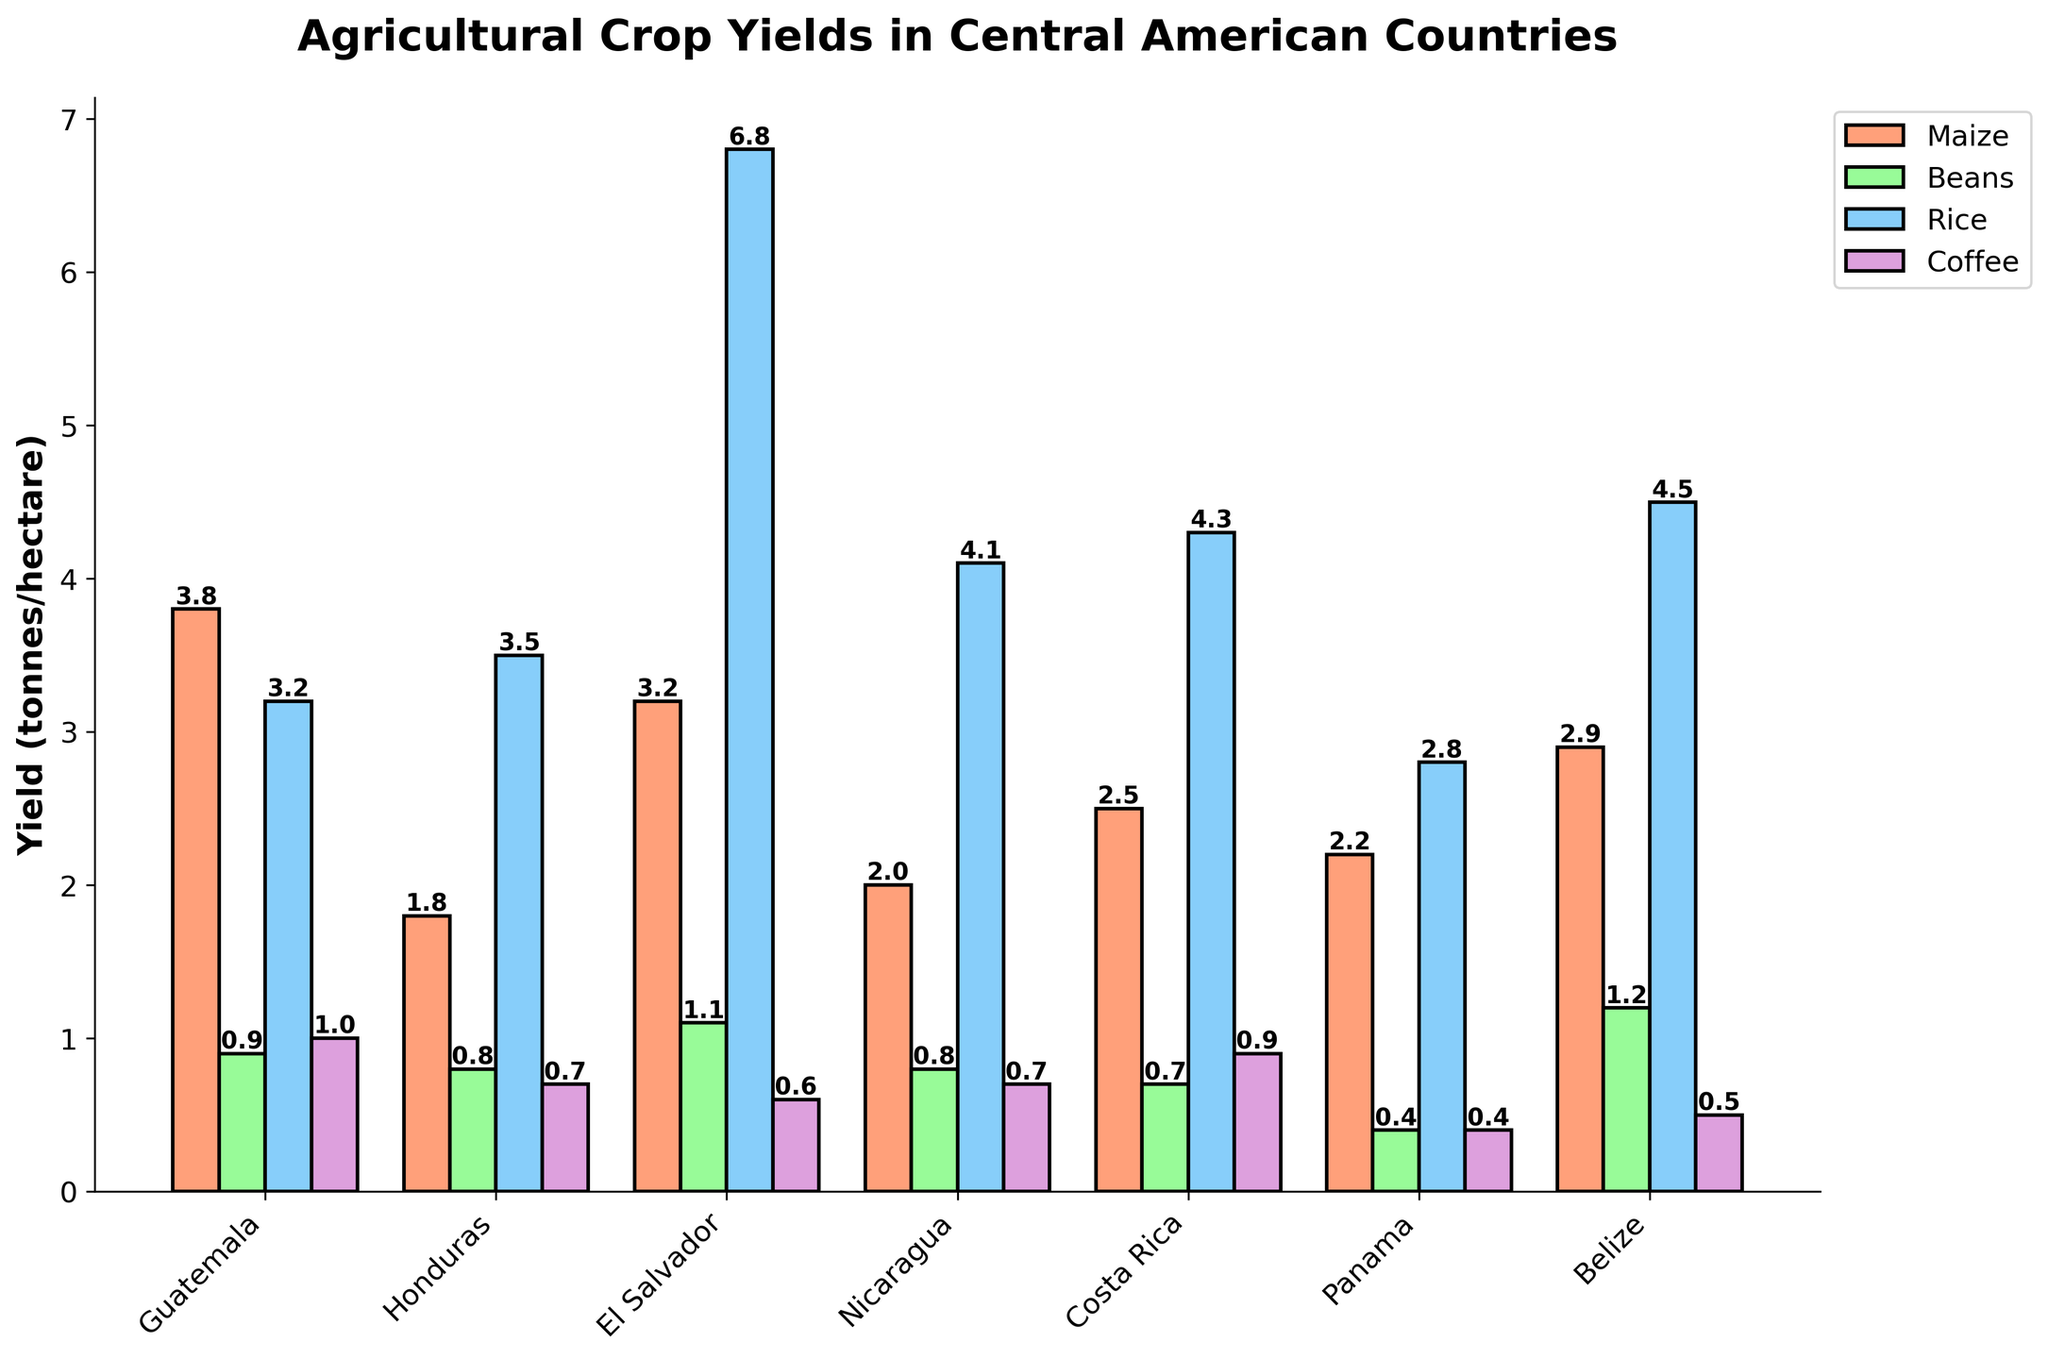What's the highest yield of rice among the countries? The highest bar for rice (colored blue) represents the country with the highest yield which is El Salvador at 6.8 tonnes/hectare.
Answer: El Salvador Which country has the lowest yield in beans? The shortest bar for beans (colored green) is Panama with a yield of 0.4 tonnes/hectare.
Answer: Panama Compare the maize and sugarcane yields in Guatemala. Which is higher and by how much? Comparing the heights of the corresponding bars for maize and sugarcane in Guatemala, maize is at 3.8 and sugarcane is at 118.5. The difference is 118.5 - 3.8 = 114.7 tonnes/hectare in favor of sugarcane.
Answer: Sugarcane by 114.7 What is the average yield of coffee across all the countries? Adding the yields for coffee (1.0 + 0.7 + 0.6 + 0.7 + 0.9 + 0.4 + 0.5) gives 4.8. Dividing by the number of countries (7) results in an average yield of 4.8 / 7 ≈ 0.69 tonnes/hectare.
Answer: 0.69 Which country has the most balanced yields across all four crops (maize, beans, rice, coffee)? Observing the bar heights for each crop across all countries, Panama has relatively balanced and lower yields compared to other countries, as none of the bars for that country deviate drastically.
Answer: Panama Which crop has the highest overall yield across all countries? The highest bars in the figure belong to sugarcane in Guatemala, indicating sugarcane has the highest yield overall across all countries.
Answer: Sugarcane What is the total yield of beans in Belize and Costa Rica combined? The yield for beans in Belize is 1.2 and in Costa Rica is 0.7. Adding these values gives 1.2 + 0.7 = 1.9 tonnes/hectare.
Answer: 1.9 How does the yield of rice in Nicaragua compare to that in Belize? The height of the rice bar in Nicaragua (4.1) is slightly lower than in Belize (4.5), showing Belize has a higher yield.
Answer: Belize higher What is the difference in sugarcane yield between the country with the highest and the country with the lowest yield? The highest sugarcane yield is in Guatemala at 118.5, and the lowest is in Panama at 56.9. The difference is 118.5 - 56.9 = 61.6 tonnes/hectare.
Answer: 61.6 Which country has the highest yield of maize, and how much is it? The tallest bar for maize (colored orange) is Guatemala with a yield of 3.8 tonnes/hectare.
Answer: Guatemala, 3.8 